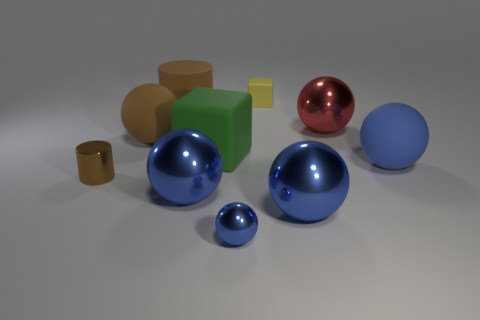Is the material of the large blue thing left of the tiny matte object the same as the tiny brown cylinder?
Ensure brevity in your answer.  Yes. There is a small object that is in front of the brown object in front of the matte sphere right of the tiny yellow matte block; what is its shape?
Your answer should be compact. Sphere. Is there another thing of the same size as the green matte thing?
Your answer should be very brief. Yes. The brown rubber cylinder is what size?
Provide a short and direct response. Large. How many other metal objects have the same size as the green object?
Provide a short and direct response. 3. Is the number of large green rubber things behind the big red ball less than the number of metal objects that are in front of the small brown cylinder?
Give a very brief answer. Yes. There is a red metallic ball right of the large blue metallic thing to the left of the blue shiny object that is right of the yellow thing; how big is it?
Give a very brief answer. Large. How big is the thing that is both on the right side of the small ball and behind the red thing?
Your response must be concise. Small. What shape is the large blue shiny object that is to the left of the tiny object that is behind the big brown rubber cylinder?
Make the answer very short. Sphere. Is there anything else that has the same color as the tiny matte cube?
Your answer should be very brief. No. 